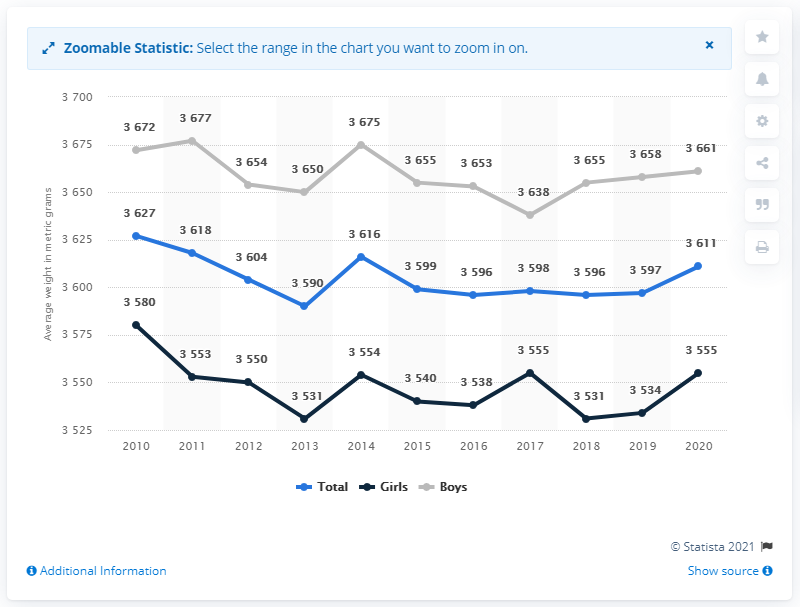Outline some significant characteristics in this image. The blue line is the one that always stays in the middle. In 2017, there was an increase in the average birth weight of all babies born, despite a decrease in the average birth weight of male babies. 